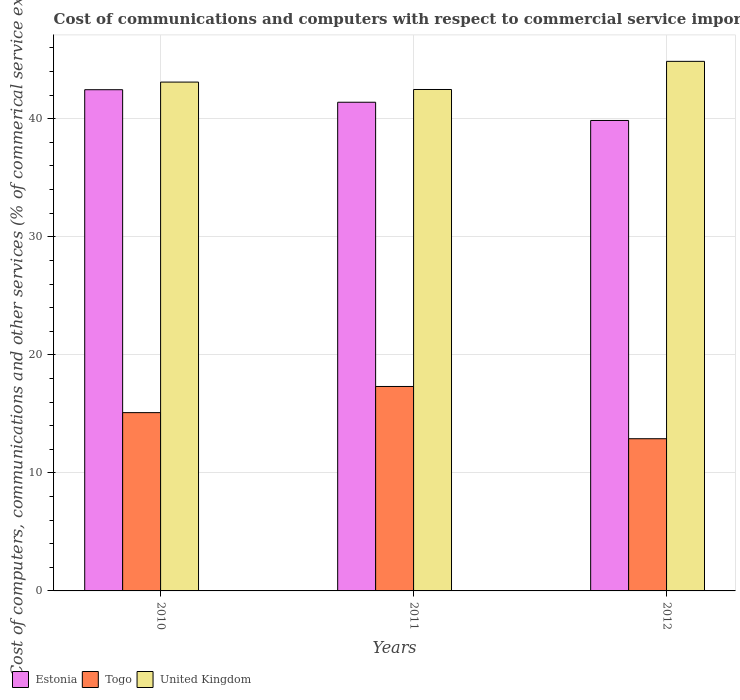Are the number of bars on each tick of the X-axis equal?
Make the answer very short. Yes. How many bars are there on the 2nd tick from the left?
Your answer should be very brief. 3. In how many cases, is the number of bars for a given year not equal to the number of legend labels?
Keep it short and to the point. 0. What is the cost of communications and computers in Togo in 2010?
Your answer should be compact. 15.1. Across all years, what is the maximum cost of communications and computers in United Kingdom?
Give a very brief answer. 44.86. Across all years, what is the minimum cost of communications and computers in Togo?
Keep it short and to the point. 12.89. In which year was the cost of communications and computers in United Kingdom maximum?
Ensure brevity in your answer.  2012. What is the total cost of communications and computers in Estonia in the graph?
Your answer should be very brief. 123.71. What is the difference between the cost of communications and computers in Togo in 2010 and that in 2011?
Offer a terse response. -2.22. What is the difference between the cost of communications and computers in United Kingdom in 2011 and the cost of communications and computers in Togo in 2010?
Ensure brevity in your answer.  27.37. What is the average cost of communications and computers in Estonia per year?
Provide a short and direct response. 41.24. In the year 2010, what is the difference between the cost of communications and computers in Estonia and cost of communications and computers in United Kingdom?
Give a very brief answer. -0.65. What is the ratio of the cost of communications and computers in Togo in 2010 to that in 2011?
Provide a short and direct response. 0.87. Is the difference between the cost of communications and computers in Estonia in 2010 and 2012 greater than the difference between the cost of communications and computers in United Kingdom in 2010 and 2012?
Provide a short and direct response. Yes. What is the difference between the highest and the second highest cost of communications and computers in United Kingdom?
Ensure brevity in your answer.  1.76. What is the difference between the highest and the lowest cost of communications and computers in Togo?
Offer a terse response. 4.43. In how many years, is the cost of communications and computers in United Kingdom greater than the average cost of communications and computers in United Kingdom taken over all years?
Offer a very short reply. 1. Is the sum of the cost of communications and computers in United Kingdom in 2010 and 2011 greater than the maximum cost of communications and computers in Estonia across all years?
Offer a terse response. Yes. What does the 1st bar from the left in 2011 represents?
Give a very brief answer. Estonia. Are all the bars in the graph horizontal?
Your response must be concise. No. How many years are there in the graph?
Your answer should be very brief. 3. Does the graph contain any zero values?
Offer a very short reply. No. How many legend labels are there?
Make the answer very short. 3. How are the legend labels stacked?
Make the answer very short. Horizontal. What is the title of the graph?
Your answer should be very brief. Cost of communications and computers with respect to commercial service imports. What is the label or title of the X-axis?
Your answer should be very brief. Years. What is the label or title of the Y-axis?
Keep it short and to the point. Cost of computers, communications and other services (% of commerical service exports). What is the Cost of computers, communications and other services (% of commerical service exports) in Estonia in 2010?
Make the answer very short. 42.46. What is the Cost of computers, communications and other services (% of commerical service exports) of Togo in 2010?
Your response must be concise. 15.1. What is the Cost of computers, communications and other services (% of commerical service exports) of United Kingdom in 2010?
Offer a very short reply. 43.11. What is the Cost of computers, communications and other services (% of commerical service exports) in Estonia in 2011?
Your response must be concise. 41.4. What is the Cost of computers, communications and other services (% of commerical service exports) in Togo in 2011?
Provide a succinct answer. 17.32. What is the Cost of computers, communications and other services (% of commerical service exports) of United Kingdom in 2011?
Offer a terse response. 42.48. What is the Cost of computers, communications and other services (% of commerical service exports) in Estonia in 2012?
Provide a succinct answer. 39.85. What is the Cost of computers, communications and other services (% of commerical service exports) of Togo in 2012?
Ensure brevity in your answer.  12.89. What is the Cost of computers, communications and other services (% of commerical service exports) of United Kingdom in 2012?
Your response must be concise. 44.86. Across all years, what is the maximum Cost of computers, communications and other services (% of commerical service exports) in Estonia?
Provide a short and direct response. 42.46. Across all years, what is the maximum Cost of computers, communications and other services (% of commerical service exports) in Togo?
Ensure brevity in your answer.  17.32. Across all years, what is the maximum Cost of computers, communications and other services (% of commerical service exports) of United Kingdom?
Offer a terse response. 44.86. Across all years, what is the minimum Cost of computers, communications and other services (% of commerical service exports) in Estonia?
Offer a terse response. 39.85. Across all years, what is the minimum Cost of computers, communications and other services (% of commerical service exports) of Togo?
Ensure brevity in your answer.  12.89. Across all years, what is the minimum Cost of computers, communications and other services (% of commerical service exports) in United Kingdom?
Ensure brevity in your answer.  42.48. What is the total Cost of computers, communications and other services (% of commerical service exports) in Estonia in the graph?
Give a very brief answer. 123.71. What is the total Cost of computers, communications and other services (% of commerical service exports) in Togo in the graph?
Ensure brevity in your answer.  45.32. What is the total Cost of computers, communications and other services (% of commerical service exports) of United Kingdom in the graph?
Your response must be concise. 130.45. What is the difference between the Cost of computers, communications and other services (% of commerical service exports) of Estonia in 2010 and that in 2011?
Offer a very short reply. 1.06. What is the difference between the Cost of computers, communications and other services (% of commerical service exports) of Togo in 2010 and that in 2011?
Your answer should be very brief. -2.22. What is the difference between the Cost of computers, communications and other services (% of commerical service exports) in United Kingdom in 2010 and that in 2011?
Offer a very short reply. 0.63. What is the difference between the Cost of computers, communications and other services (% of commerical service exports) in Estonia in 2010 and that in 2012?
Keep it short and to the point. 2.61. What is the difference between the Cost of computers, communications and other services (% of commerical service exports) of Togo in 2010 and that in 2012?
Make the answer very short. 2.21. What is the difference between the Cost of computers, communications and other services (% of commerical service exports) in United Kingdom in 2010 and that in 2012?
Ensure brevity in your answer.  -1.76. What is the difference between the Cost of computers, communications and other services (% of commerical service exports) in Estonia in 2011 and that in 2012?
Provide a succinct answer. 1.55. What is the difference between the Cost of computers, communications and other services (% of commerical service exports) in Togo in 2011 and that in 2012?
Keep it short and to the point. 4.43. What is the difference between the Cost of computers, communications and other services (% of commerical service exports) of United Kingdom in 2011 and that in 2012?
Give a very brief answer. -2.38. What is the difference between the Cost of computers, communications and other services (% of commerical service exports) in Estonia in 2010 and the Cost of computers, communications and other services (% of commerical service exports) in Togo in 2011?
Provide a short and direct response. 25.14. What is the difference between the Cost of computers, communications and other services (% of commerical service exports) of Estonia in 2010 and the Cost of computers, communications and other services (% of commerical service exports) of United Kingdom in 2011?
Offer a very short reply. -0.02. What is the difference between the Cost of computers, communications and other services (% of commerical service exports) in Togo in 2010 and the Cost of computers, communications and other services (% of commerical service exports) in United Kingdom in 2011?
Your answer should be very brief. -27.37. What is the difference between the Cost of computers, communications and other services (% of commerical service exports) of Estonia in 2010 and the Cost of computers, communications and other services (% of commerical service exports) of Togo in 2012?
Your answer should be compact. 29.57. What is the difference between the Cost of computers, communications and other services (% of commerical service exports) of Estonia in 2010 and the Cost of computers, communications and other services (% of commerical service exports) of United Kingdom in 2012?
Provide a succinct answer. -2.4. What is the difference between the Cost of computers, communications and other services (% of commerical service exports) in Togo in 2010 and the Cost of computers, communications and other services (% of commerical service exports) in United Kingdom in 2012?
Provide a succinct answer. -29.76. What is the difference between the Cost of computers, communications and other services (% of commerical service exports) in Estonia in 2011 and the Cost of computers, communications and other services (% of commerical service exports) in Togo in 2012?
Your answer should be very brief. 28.51. What is the difference between the Cost of computers, communications and other services (% of commerical service exports) in Estonia in 2011 and the Cost of computers, communications and other services (% of commerical service exports) in United Kingdom in 2012?
Offer a very short reply. -3.46. What is the difference between the Cost of computers, communications and other services (% of commerical service exports) of Togo in 2011 and the Cost of computers, communications and other services (% of commerical service exports) of United Kingdom in 2012?
Provide a short and direct response. -27.54. What is the average Cost of computers, communications and other services (% of commerical service exports) of Estonia per year?
Your answer should be very brief. 41.24. What is the average Cost of computers, communications and other services (% of commerical service exports) in Togo per year?
Offer a very short reply. 15.11. What is the average Cost of computers, communications and other services (% of commerical service exports) of United Kingdom per year?
Your answer should be compact. 43.48. In the year 2010, what is the difference between the Cost of computers, communications and other services (% of commerical service exports) in Estonia and Cost of computers, communications and other services (% of commerical service exports) in Togo?
Your answer should be compact. 27.36. In the year 2010, what is the difference between the Cost of computers, communications and other services (% of commerical service exports) of Estonia and Cost of computers, communications and other services (% of commerical service exports) of United Kingdom?
Offer a terse response. -0.65. In the year 2010, what is the difference between the Cost of computers, communications and other services (% of commerical service exports) of Togo and Cost of computers, communications and other services (% of commerical service exports) of United Kingdom?
Your answer should be compact. -28. In the year 2011, what is the difference between the Cost of computers, communications and other services (% of commerical service exports) in Estonia and Cost of computers, communications and other services (% of commerical service exports) in Togo?
Keep it short and to the point. 24.08. In the year 2011, what is the difference between the Cost of computers, communications and other services (% of commerical service exports) of Estonia and Cost of computers, communications and other services (% of commerical service exports) of United Kingdom?
Your response must be concise. -1.08. In the year 2011, what is the difference between the Cost of computers, communications and other services (% of commerical service exports) in Togo and Cost of computers, communications and other services (% of commerical service exports) in United Kingdom?
Your answer should be very brief. -25.16. In the year 2012, what is the difference between the Cost of computers, communications and other services (% of commerical service exports) in Estonia and Cost of computers, communications and other services (% of commerical service exports) in Togo?
Give a very brief answer. 26.96. In the year 2012, what is the difference between the Cost of computers, communications and other services (% of commerical service exports) of Estonia and Cost of computers, communications and other services (% of commerical service exports) of United Kingdom?
Your answer should be compact. -5.01. In the year 2012, what is the difference between the Cost of computers, communications and other services (% of commerical service exports) of Togo and Cost of computers, communications and other services (% of commerical service exports) of United Kingdom?
Your answer should be compact. -31.97. What is the ratio of the Cost of computers, communications and other services (% of commerical service exports) of Estonia in 2010 to that in 2011?
Provide a succinct answer. 1.03. What is the ratio of the Cost of computers, communications and other services (% of commerical service exports) in Togo in 2010 to that in 2011?
Your answer should be very brief. 0.87. What is the ratio of the Cost of computers, communications and other services (% of commerical service exports) of United Kingdom in 2010 to that in 2011?
Give a very brief answer. 1.01. What is the ratio of the Cost of computers, communications and other services (% of commerical service exports) in Estonia in 2010 to that in 2012?
Provide a short and direct response. 1.07. What is the ratio of the Cost of computers, communications and other services (% of commerical service exports) in Togo in 2010 to that in 2012?
Make the answer very short. 1.17. What is the ratio of the Cost of computers, communications and other services (% of commerical service exports) in United Kingdom in 2010 to that in 2012?
Your answer should be very brief. 0.96. What is the ratio of the Cost of computers, communications and other services (% of commerical service exports) of Estonia in 2011 to that in 2012?
Keep it short and to the point. 1.04. What is the ratio of the Cost of computers, communications and other services (% of commerical service exports) in Togo in 2011 to that in 2012?
Your answer should be very brief. 1.34. What is the ratio of the Cost of computers, communications and other services (% of commerical service exports) in United Kingdom in 2011 to that in 2012?
Your response must be concise. 0.95. What is the difference between the highest and the second highest Cost of computers, communications and other services (% of commerical service exports) of Estonia?
Offer a very short reply. 1.06. What is the difference between the highest and the second highest Cost of computers, communications and other services (% of commerical service exports) of Togo?
Give a very brief answer. 2.22. What is the difference between the highest and the second highest Cost of computers, communications and other services (% of commerical service exports) in United Kingdom?
Provide a succinct answer. 1.76. What is the difference between the highest and the lowest Cost of computers, communications and other services (% of commerical service exports) of Estonia?
Make the answer very short. 2.61. What is the difference between the highest and the lowest Cost of computers, communications and other services (% of commerical service exports) in Togo?
Your answer should be very brief. 4.43. What is the difference between the highest and the lowest Cost of computers, communications and other services (% of commerical service exports) in United Kingdom?
Ensure brevity in your answer.  2.38. 